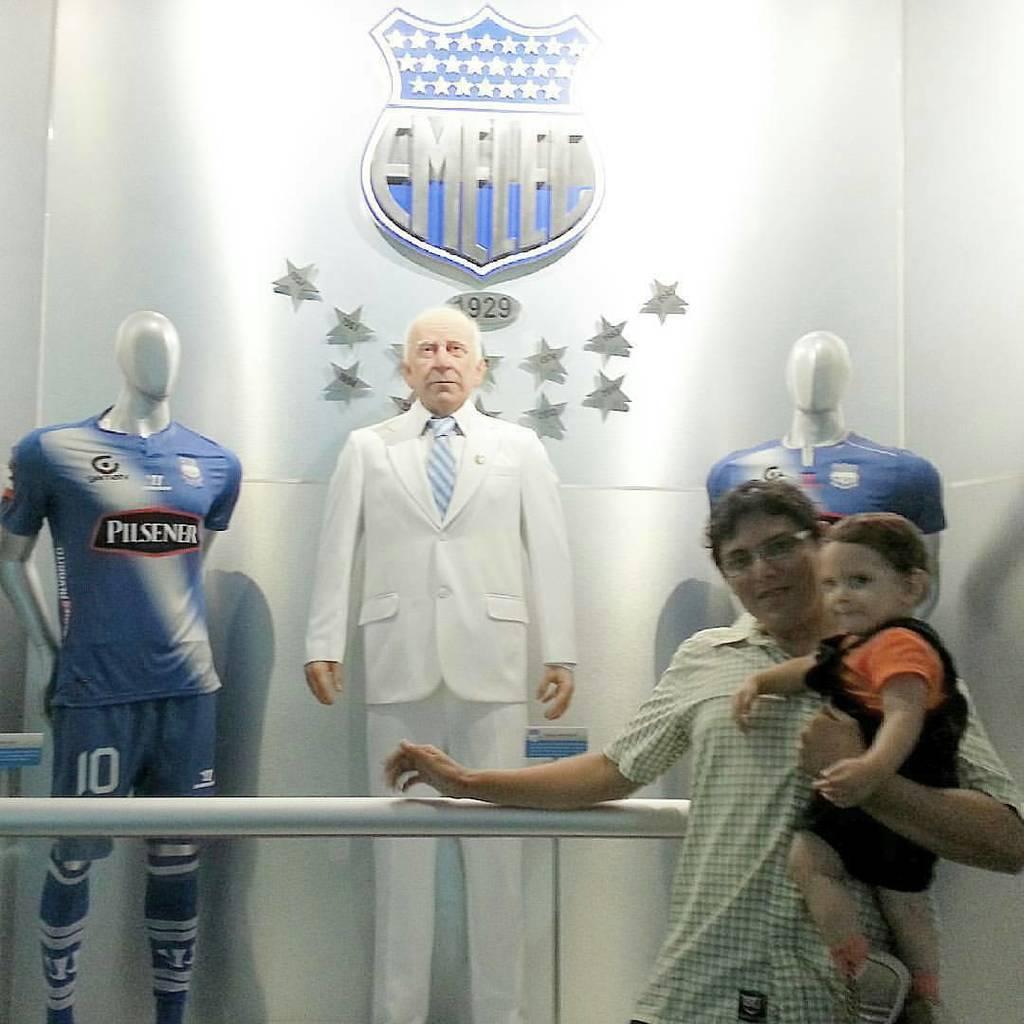What is the year beneath the logo?
Offer a very short reply. 1929. 